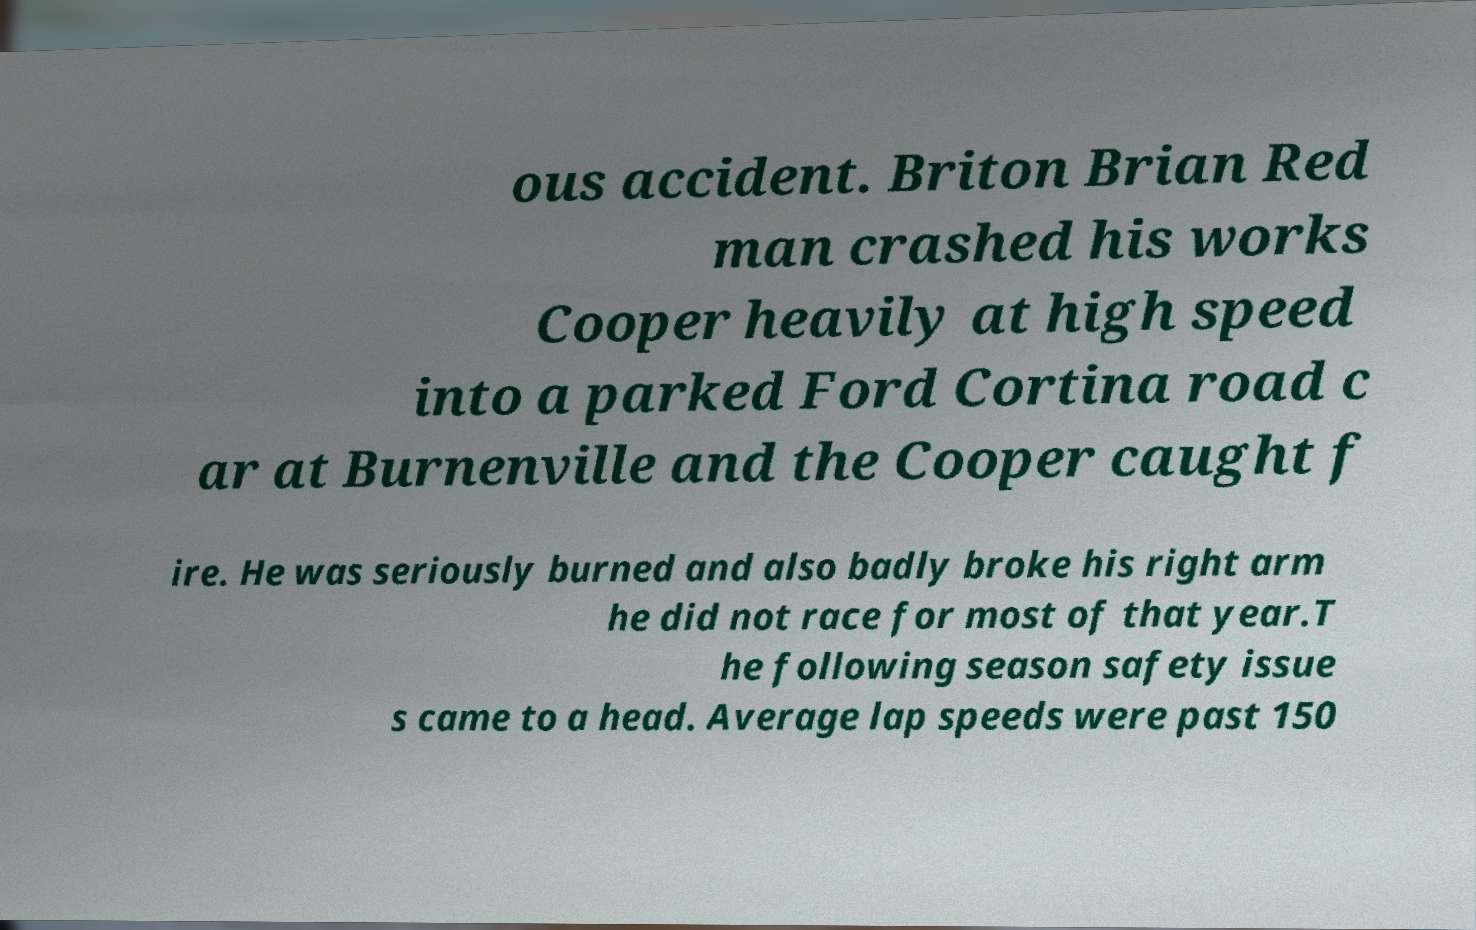What messages or text are displayed in this image? I need them in a readable, typed format. ous accident. Briton Brian Red man crashed his works Cooper heavily at high speed into a parked Ford Cortina road c ar at Burnenville and the Cooper caught f ire. He was seriously burned and also badly broke his right arm he did not race for most of that year.T he following season safety issue s came to a head. Average lap speeds were past 150 